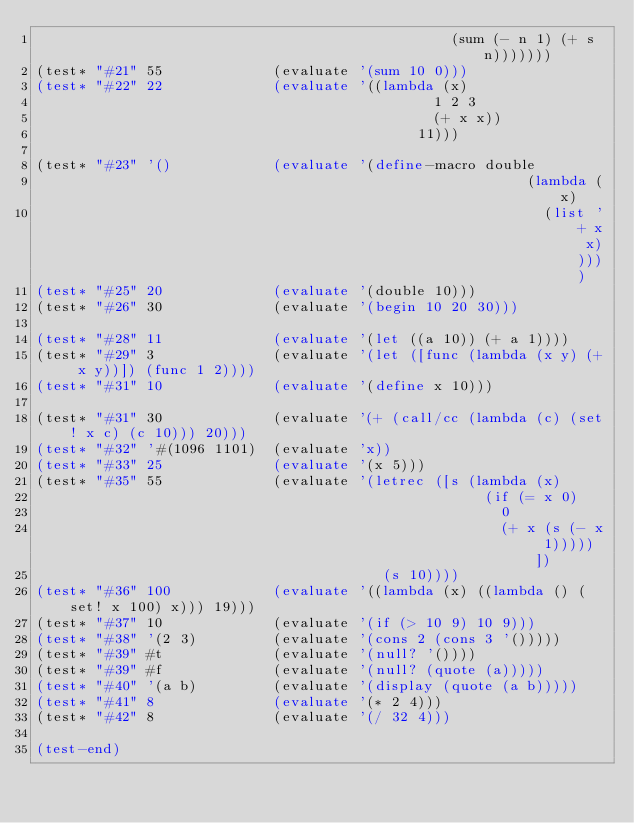<code> <loc_0><loc_0><loc_500><loc_500><_Scheme_>                                                 (sum (- n 1) (+ s n)))))))
(test* "#21" 55             (evaluate '(sum 10 0)))
(test* "#22" 22             (evaluate '((lambda (x)
                                               1 2 3
                                               (+ x x))
                                             11)))

(test* "#23" '()            (evaluate '(define-macro double
                                                          (lambda (x)
                                                            (list '+ x x)))))
(test* "#25" 20             (evaluate '(double 10)))
(test* "#26" 30             (evaluate '(begin 10 20 30)))

(test* "#28" 11             (evaluate '(let ((a 10)) (+ a 1))))
(test* "#29" 3              (evaluate '(let ([func (lambda (x y) (+ x y))]) (func 1 2))))
(test* "#31" 10             (evaluate '(define x 10)))

(test* "#31" 30             (evaluate '(+ (call/cc (lambda (c) (set! x c) (c 10))) 20)))
(test* "#32" '#(1096 1101)  (evaluate 'x))
(test* "#33" 25             (evaluate '(x 5)))
(test* "#35" 55             (evaluate '(letrec ([s (lambda (x)
                                                     (if (= x 0)
                                                       0
                                                       (+ x (s (- x 1)))))])
                                         (s 10))))
(test* "#36" 100            (evaluate '((lambda (x) ((lambda () (set! x 100) x))) 19)))
(test* "#37" 10             (evaluate '(if (> 10 9) 10 9)))
(test* "#38" '(2 3)         (evaluate '(cons 2 (cons 3 '()))))
(test* "#39" #t             (evaluate '(null? '())))
(test* "#39" #f             (evaluate '(null? (quote (a)))))
(test* "#40" '(a b)         (evaluate '(display (quote (a b)))))
(test* "#41" 8	            (evaluate '(* 2 4)))
(test* "#42" 8	            (evaluate '(/ 32 4)))

(test-end)
</code> 